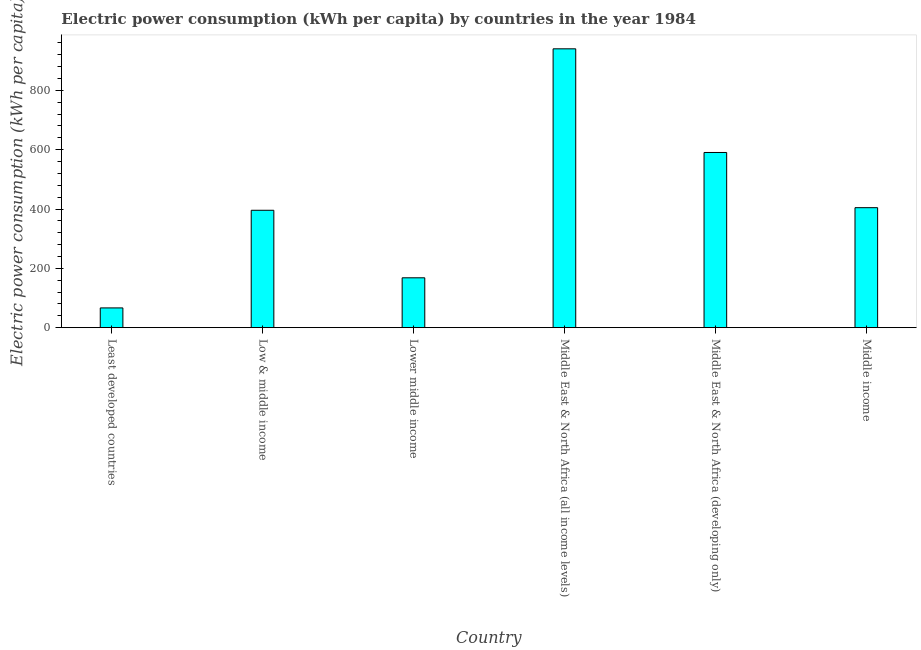Does the graph contain any zero values?
Provide a short and direct response. No. Does the graph contain grids?
Offer a terse response. No. What is the title of the graph?
Keep it short and to the point. Electric power consumption (kWh per capita) by countries in the year 1984. What is the label or title of the X-axis?
Offer a very short reply. Country. What is the label or title of the Y-axis?
Give a very brief answer. Electric power consumption (kWh per capita). What is the electric power consumption in Middle East & North Africa (developing only)?
Provide a short and direct response. 590.71. Across all countries, what is the maximum electric power consumption?
Make the answer very short. 940.24. Across all countries, what is the minimum electric power consumption?
Offer a very short reply. 66.6. In which country was the electric power consumption maximum?
Give a very brief answer. Middle East & North Africa (all income levels). In which country was the electric power consumption minimum?
Make the answer very short. Least developed countries. What is the sum of the electric power consumption?
Provide a succinct answer. 2566.11. What is the difference between the electric power consumption in Least developed countries and Middle income?
Provide a short and direct response. -337.99. What is the average electric power consumption per country?
Keep it short and to the point. 427.68. What is the median electric power consumption?
Offer a very short reply. 400.21. In how many countries, is the electric power consumption greater than 760 kWh per capita?
Ensure brevity in your answer.  1. What is the ratio of the electric power consumption in Lower middle income to that in Middle income?
Offer a very short reply. 0.42. What is the difference between the highest and the second highest electric power consumption?
Your answer should be very brief. 349.54. Is the sum of the electric power consumption in Lower middle income and Middle East & North Africa (developing only) greater than the maximum electric power consumption across all countries?
Provide a succinct answer. No. What is the difference between the highest and the lowest electric power consumption?
Provide a succinct answer. 873.65. In how many countries, is the electric power consumption greater than the average electric power consumption taken over all countries?
Give a very brief answer. 2. How many countries are there in the graph?
Keep it short and to the point. 6. Are the values on the major ticks of Y-axis written in scientific E-notation?
Make the answer very short. No. What is the Electric power consumption (kWh per capita) in Least developed countries?
Offer a very short reply. 66.6. What is the Electric power consumption (kWh per capita) of Low & middle income?
Your answer should be compact. 395.84. What is the Electric power consumption (kWh per capita) in Lower middle income?
Your answer should be compact. 168.14. What is the Electric power consumption (kWh per capita) in Middle East & North Africa (all income levels)?
Ensure brevity in your answer.  940.24. What is the Electric power consumption (kWh per capita) in Middle East & North Africa (developing only)?
Offer a terse response. 590.71. What is the Electric power consumption (kWh per capita) of Middle income?
Provide a succinct answer. 404.58. What is the difference between the Electric power consumption (kWh per capita) in Least developed countries and Low & middle income?
Make the answer very short. -329.24. What is the difference between the Electric power consumption (kWh per capita) in Least developed countries and Lower middle income?
Your answer should be very brief. -101.54. What is the difference between the Electric power consumption (kWh per capita) in Least developed countries and Middle East & North Africa (all income levels)?
Make the answer very short. -873.65. What is the difference between the Electric power consumption (kWh per capita) in Least developed countries and Middle East & North Africa (developing only)?
Offer a very short reply. -524.11. What is the difference between the Electric power consumption (kWh per capita) in Least developed countries and Middle income?
Ensure brevity in your answer.  -337.99. What is the difference between the Electric power consumption (kWh per capita) in Low & middle income and Lower middle income?
Make the answer very short. 227.7. What is the difference between the Electric power consumption (kWh per capita) in Low & middle income and Middle East & North Africa (all income levels)?
Your response must be concise. -544.41. What is the difference between the Electric power consumption (kWh per capita) in Low & middle income and Middle East & North Africa (developing only)?
Give a very brief answer. -194.87. What is the difference between the Electric power consumption (kWh per capita) in Low & middle income and Middle income?
Make the answer very short. -8.74. What is the difference between the Electric power consumption (kWh per capita) in Lower middle income and Middle East & North Africa (all income levels)?
Your answer should be very brief. -772.11. What is the difference between the Electric power consumption (kWh per capita) in Lower middle income and Middle East & North Africa (developing only)?
Provide a succinct answer. -422.57. What is the difference between the Electric power consumption (kWh per capita) in Lower middle income and Middle income?
Offer a very short reply. -236.44. What is the difference between the Electric power consumption (kWh per capita) in Middle East & North Africa (all income levels) and Middle East & North Africa (developing only)?
Offer a very short reply. 349.54. What is the difference between the Electric power consumption (kWh per capita) in Middle East & North Africa (all income levels) and Middle income?
Your response must be concise. 535.66. What is the difference between the Electric power consumption (kWh per capita) in Middle East & North Africa (developing only) and Middle income?
Make the answer very short. 186.12. What is the ratio of the Electric power consumption (kWh per capita) in Least developed countries to that in Low & middle income?
Offer a terse response. 0.17. What is the ratio of the Electric power consumption (kWh per capita) in Least developed countries to that in Lower middle income?
Your answer should be compact. 0.4. What is the ratio of the Electric power consumption (kWh per capita) in Least developed countries to that in Middle East & North Africa (all income levels)?
Provide a short and direct response. 0.07. What is the ratio of the Electric power consumption (kWh per capita) in Least developed countries to that in Middle East & North Africa (developing only)?
Keep it short and to the point. 0.11. What is the ratio of the Electric power consumption (kWh per capita) in Least developed countries to that in Middle income?
Your answer should be compact. 0.17. What is the ratio of the Electric power consumption (kWh per capita) in Low & middle income to that in Lower middle income?
Ensure brevity in your answer.  2.35. What is the ratio of the Electric power consumption (kWh per capita) in Low & middle income to that in Middle East & North Africa (all income levels)?
Your response must be concise. 0.42. What is the ratio of the Electric power consumption (kWh per capita) in Low & middle income to that in Middle East & North Africa (developing only)?
Provide a short and direct response. 0.67. What is the ratio of the Electric power consumption (kWh per capita) in Low & middle income to that in Middle income?
Keep it short and to the point. 0.98. What is the ratio of the Electric power consumption (kWh per capita) in Lower middle income to that in Middle East & North Africa (all income levels)?
Offer a very short reply. 0.18. What is the ratio of the Electric power consumption (kWh per capita) in Lower middle income to that in Middle East & North Africa (developing only)?
Provide a short and direct response. 0.28. What is the ratio of the Electric power consumption (kWh per capita) in Lower middle income to that in Middle income?
Your answer should be very brief. 0.42. What is the ratio of the Electric power consumption (kWh per capita) in Middle East & North Africa (all income levels) to that in Middle East & North Africa (developing only)?
Your response must be concise. 1.59. What is the ratio of the Electric power consumption (kWh per capita) in Middle East & North Africa (all income levels) to that in Middle income?
Provide a short and direct response. 2.32. What is the ratio of the Electric power consumption (kWh per capita) in Middle East & North Africa (developing only) to that in Middle income?
Make the answer very short. 1.46. 